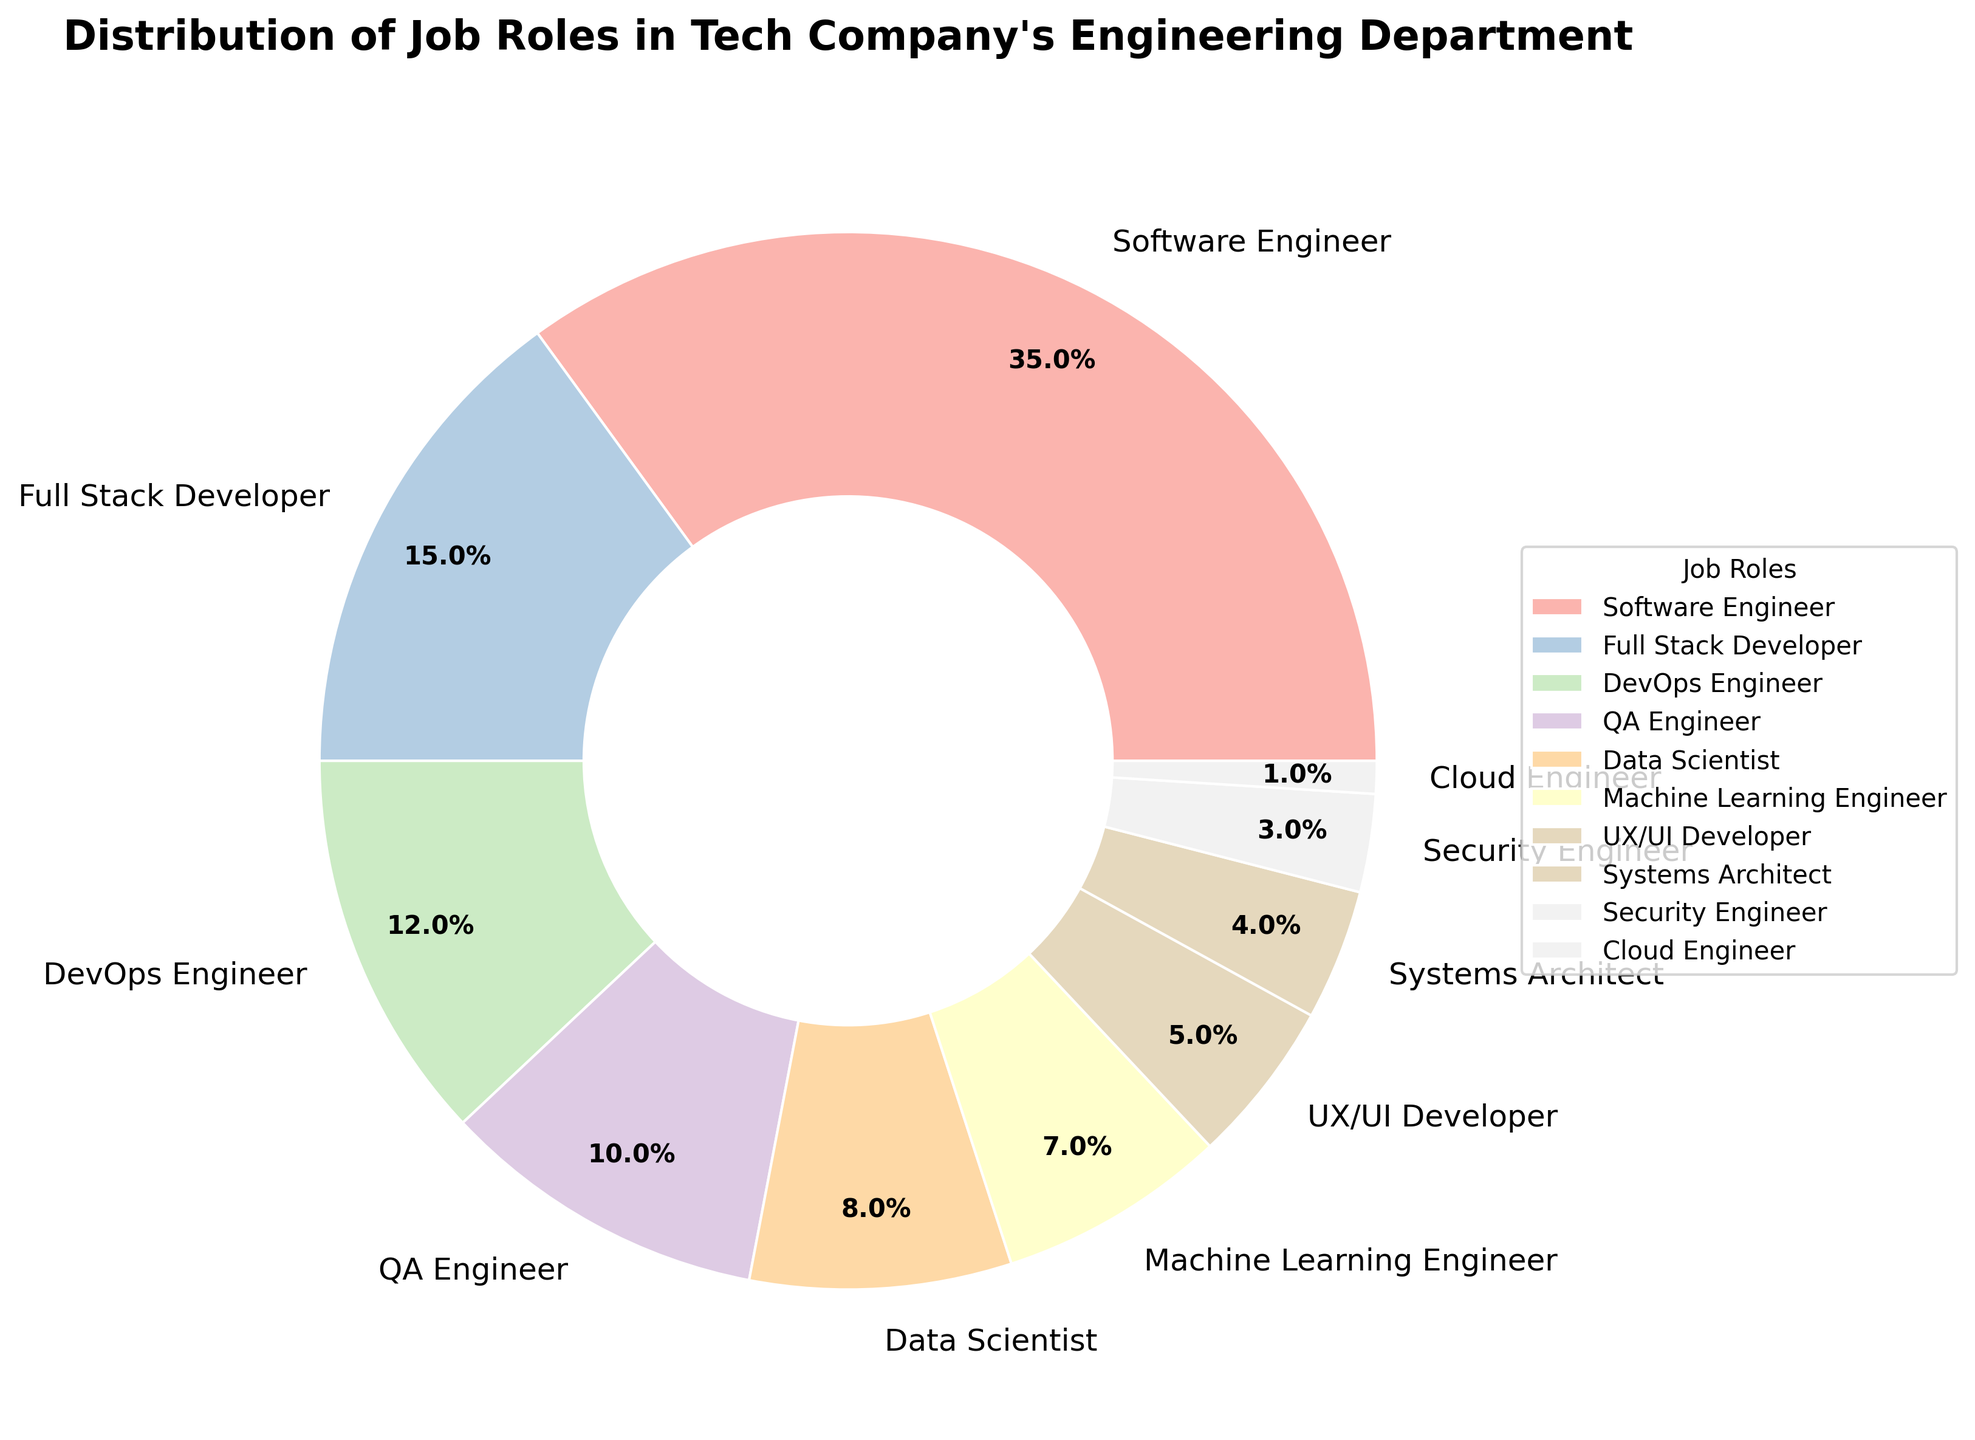What percentage of the department is made up of Software Engineers and Full Stack Developers combined? Add the percentages for Software Engineers and Full Stack Developers: 35% + 15% = 50%.
Answer: 50% Which roles together make up more than half of the department? Software Engineer (35%) and Full Stack Developer (15%) together make up 50%. Adding DevOps Engineer (12%) gives 62%, which is over half.
Answer: Software Engineer, Full Stack Developer, DevOps Engineer How much more prevalent are Software Engineers compared to Security Engineers? Subtract the percentage of Security Engineers from the percentage of Software Engineers: 35% - 3% = 32%.
Answer: 32% Identify the job role with the smallest percentage and provide its value. The role with the smallest percentage slice is Cloud Engineer, which is 1%.
Answer: Cloud Engineer, 1% Which two roles combined have nearly the same percentage as Software Engineers alone? Adding percentages for Data Scientist (8%) and Machine Learning Engineer (7%) gives 8% + 7% = 15%, which is less by 20%. For Full Stack Developer (15%) and DevOps Engineer (12%), it totals 27%, still slightly below. Finally, Data Scientist (8%) and QA Engineer (10%) sum to 18%, which is closer but still not exact.
Answer: None combine to exactly match but various pairs closely approach 35% Which role has the highest representation apart from Software Engineers? Full Stack Developers have the highest percentage following Software Engineers, with 15%.
Answer: Full Stack Developer Compare the combined percentages of UX/UI Developers and Systems Architects versus DevOps Engineers. Add UX/UI Developers and Systems Architects: 5% + 4% = 9%. DevOps Engineers have 12%. Compare the results: 9% vs 12%.
Answer: DevOps Engineers are more by 3% How many job roles make up less than 10% individually? Identify roles under 10%: Data Scientist (8%), Machine Learning Engineer (7%), UX/UI Developer (5%), Systems Architect (4%), Security Engineer (3%), Cloud Engineer (1%). This sums to six roles.
Answer: 6 What is the ratio of Software Engineers to QA Engineers in the department? Divide the percentage of Software Engineers by the percentage of QA Engineers: 35% / 10% = 3.5.
Answer: 3.5:1 Which job role has a similar percentage to the combination of UX/UI Developers and Security Engineers? Add percentages of UX/UI Developers and Security Engineers: 5% + 3% = 8%. Data Scientist has the same percentage as this combination, 8%.
Answer: Data Scientist 